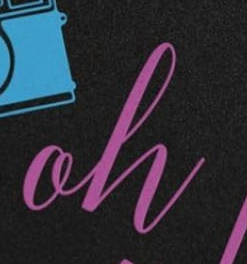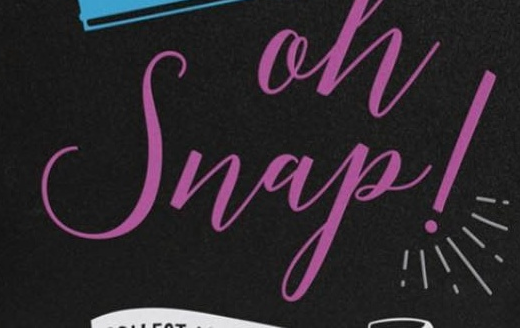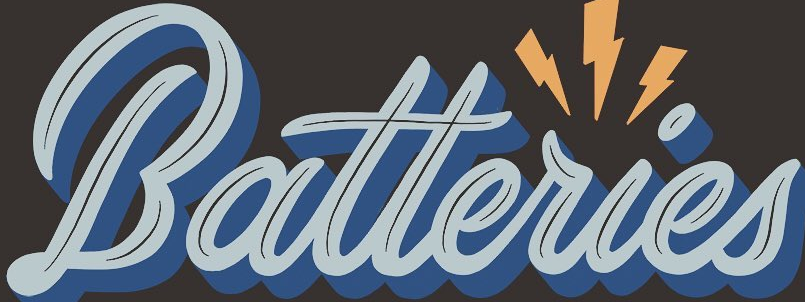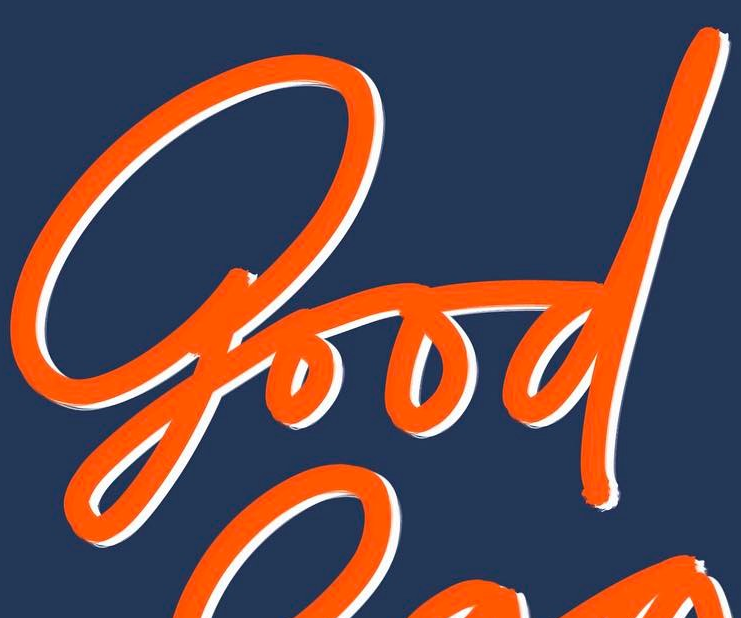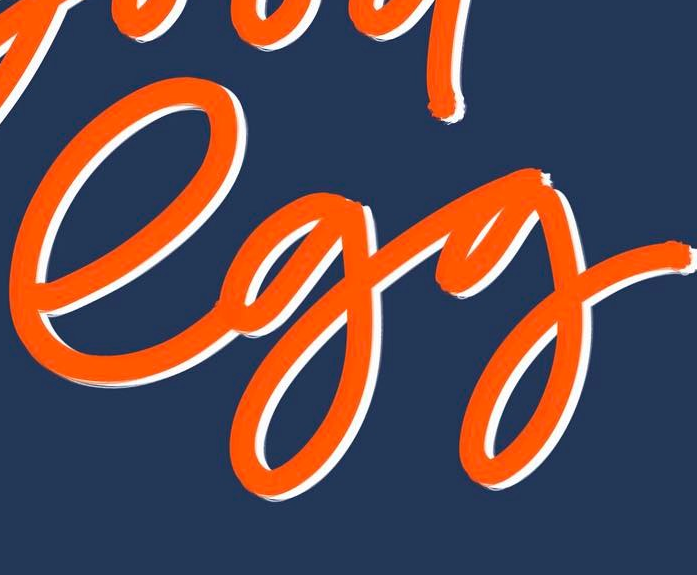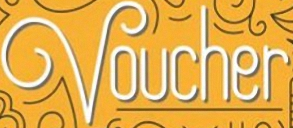Read the text content from these images in order, separated by a semicolon. oh; Snap!; Batteries; good; egg; Voucher 